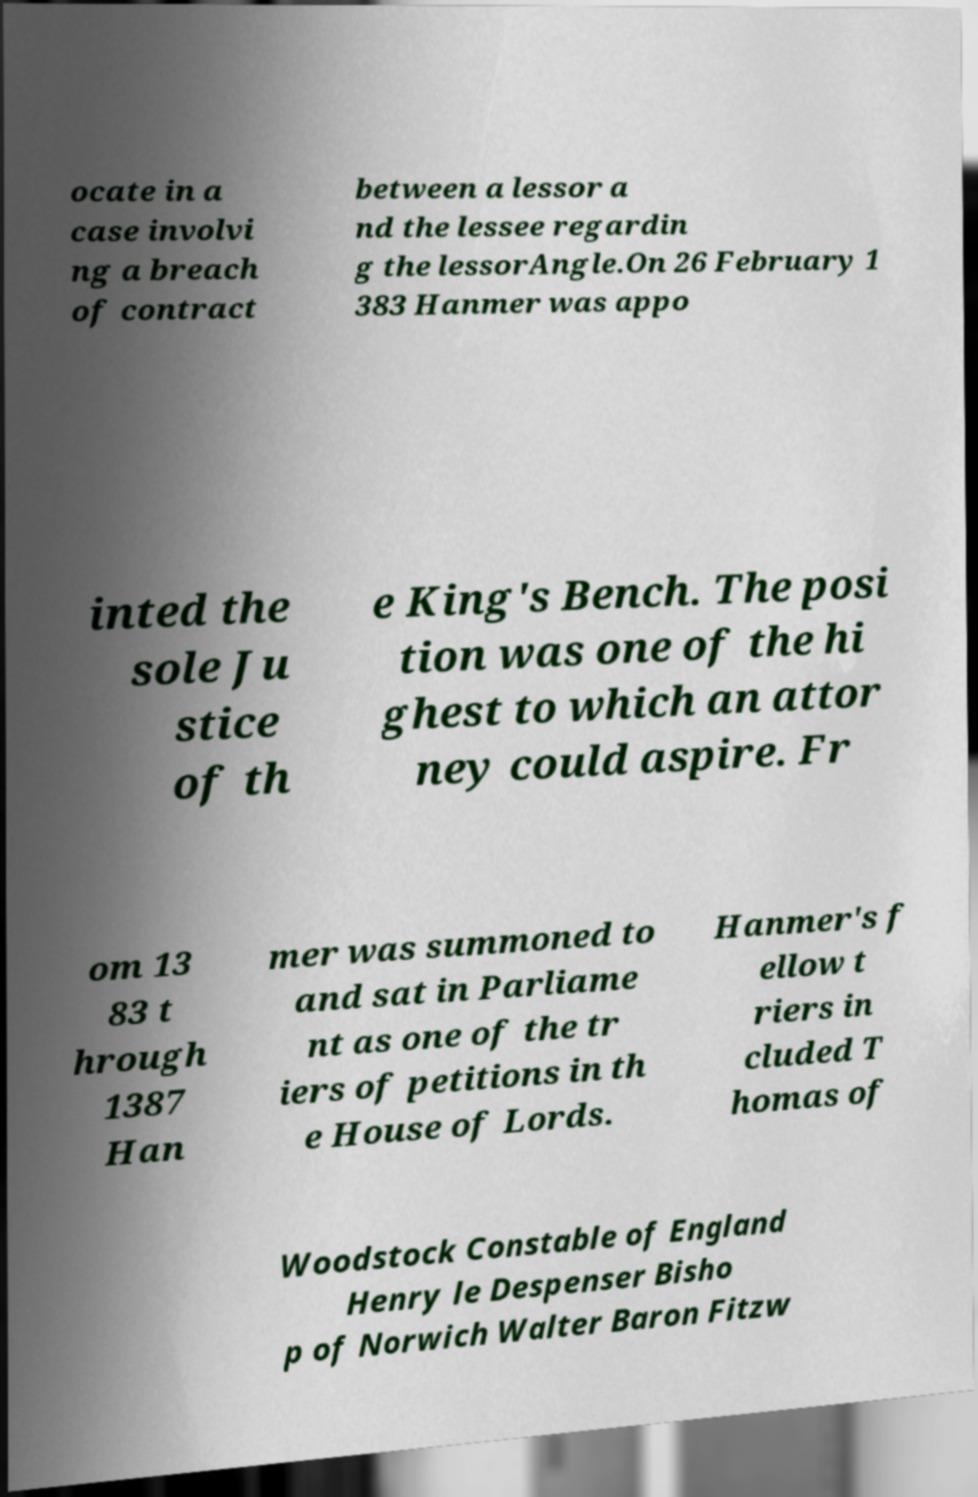Please read and relay the text visible in this image. What does it say? ocate in a case involvi ng a breach of contract between a lessor a nd the lessee regardin g the lessorAngle.On 26 February 1 383 Hanmer was appo inted the sole Ju stice of th e King's Bench. The posi tion was one of the hi ghest to which an attor ney could aspire. Fr om 13 83 t hrough 1387 Han mer was summoned to and sat in Parliame nt as one of the tr iers of petitions in th e House of Lords. Hanmer's f ellow t riers in cluded T homas of Woodstock Constable of England Henry le Despenser Bisho p of Norwich Walter Baron Fitzw 